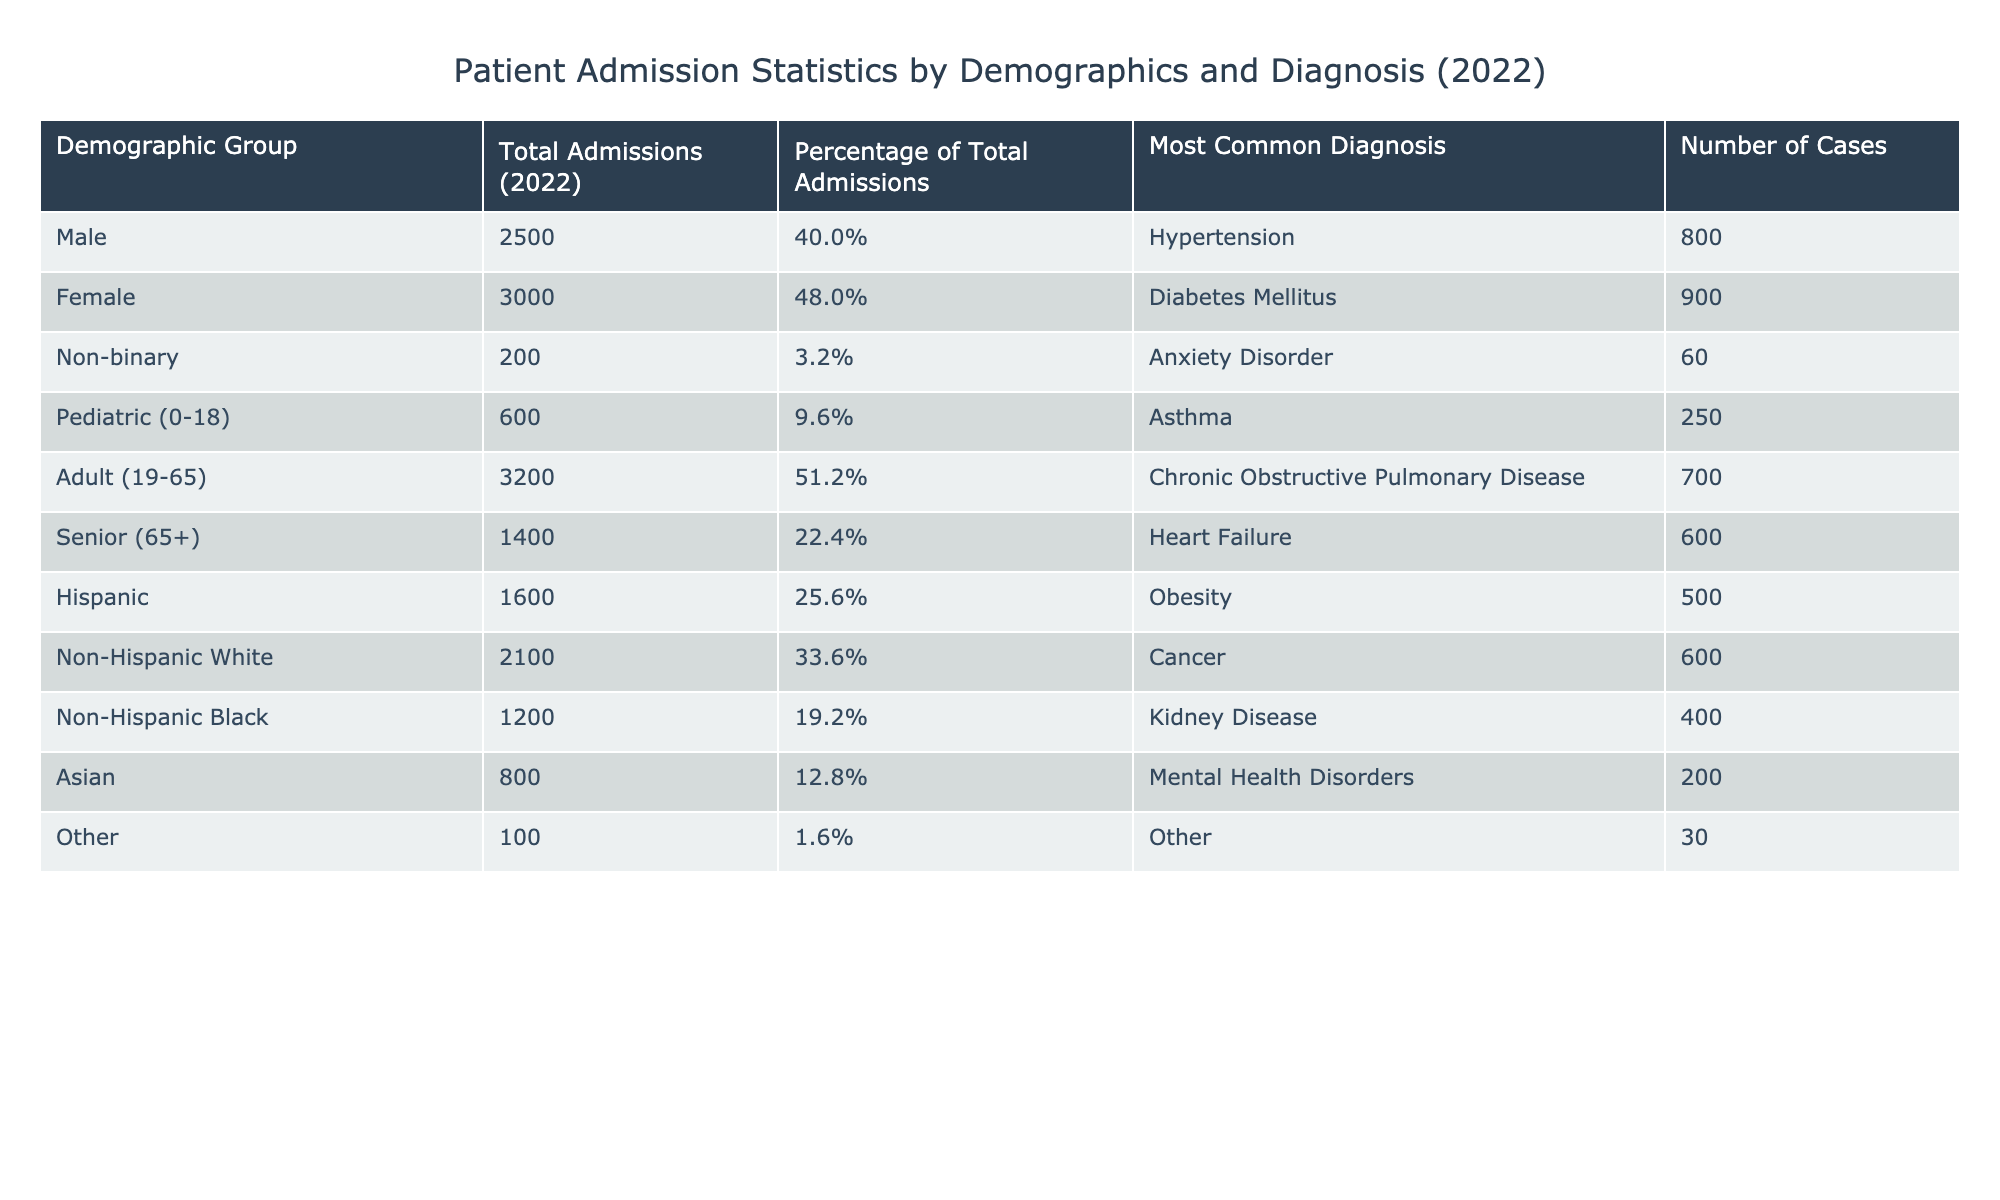What is the total number of admissions for females in 2022? The table indicates that the total admissions for females is directly stated under the "Total Admissions (2022)" column for the "Female" demographic group, which is 3000.
Answer: 3000 Which group has the highest percentage of total admissions? The percentage of total admissions for each demographic group is provided in the table. By comparing the percentages listed, "Female" has the highest percentage at 48.0%.
Answer: Female What is the most common diagnosis for pediatric patients? The table specifies "Pediatric (0-18)" in the demographic group, and under the "Most Common Diagnosis" column, it lists "Asthma" as the most common diagnosis for that age group.
Answer: Asthma What is the total number of admissions for Non-Hispanic Black patients? The admissions for Non-Hispanic Black patients can be found in the "Total Admissions (2022)" column for the "Non-Hispanic Black" demographic group, which states 1200.
Answer: 1200 Is the most common diagnosis for the senior demographic group heart failure? The table shows that for the "Senior (65+)" demographic group, the most common diagnosis listed is "Heart Failure." Therefore, the statement holds true.
Answer: Yes What is the average number of admissions for the pediatric and senior demographic groups combined? To find the average, first sum the total admissions of "Pediatric (0-18)" which is 600 and "Senior (65+)" which is 1400. This totals 600 + 1400 = 2000. Since there are two groups, the average is 2000 / 2 = 1000.
Answer: 1000 What percentage of the total admissions are accounted for by males and non-binary individuals combined? The percentages for males and non-binary individuals are 40.0% and 3.2%, respectively. Adding these percentages gives 40.0% + 3.2% = 43.2%.
Answer: 43.2% Which demographic group had the fewest total admissions, and how many were there? From observing the "Total Admissions (2022)" column, "Other" had the fewest admissions, totaling 100.
Answer: Other, 100 How many cases of diabetes mellitus were recorded in total? The most common diagnosis for females is diabetes mellitus, with the number of cases listed as 900. This is the only number provided for diabetes, indicating the total.
Answer: 900 